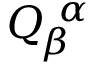Convert formula to latex. <formula><loc_0><loc_0><loc_500><loc_500>Q _ { \, \beta } ^ { \, \alpha }</formula> 